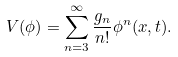Convert formula to latex. <formula><loc_0><loc_0><loc_500><loc_500>V ( \phi ) = \sum _ { n = 3 } ^ { \infty } \frac { g _ { n } } { n ! } \phi ^ { n } ( { x } , t ) .</formula> 